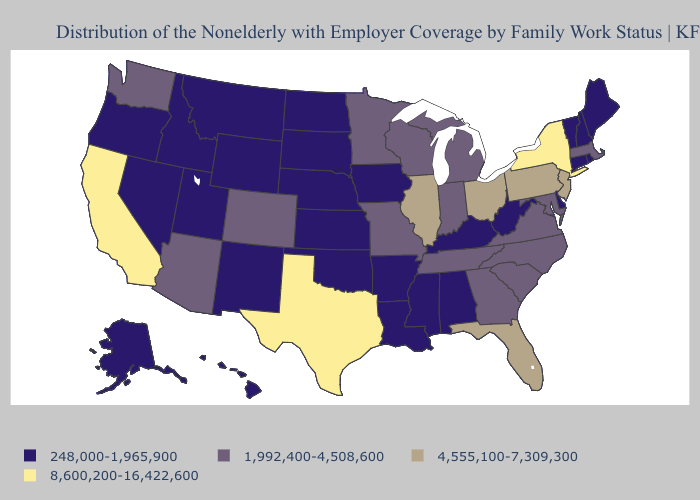Name the states that have a value in the range 8,600,200-16,422,600?
Be succinct. California, New York, Texas. Does New Jersey have the lowest value in the USA?
Write a very short answer. No. Among the states that border Texas , which have the lowest value?
Give a very brief answer. Arkansas, Louisiana, New Mexico, Oklahoma. Does the first symbol in the legend represent the smallest category?
Quick response, please. Yes. Name the states that have a value in the range 4,555,100-7,309,300?
Keep it brief. Florida, Illinois, New Jersey, Ohio, Pennsylvania. What is the value of Wyoming?
Be succinct. 248,000-1,965,900. What is the highest value in the South ?
Keep it brief. 8,600,200-16,422,600. Name the states that have a value in the range 248,000-1,965,900?
Answer briefly. Alabama, Alaska, Arkansas, Connecticut, Delaware, Hawaii, Idaho, Iowa, Kansas, Kentucky, Louisiana, Maine, Mississippi, Montana, Nebraska, Nevada, New Hampshire, New Mexico, North Dakota, Oklahoma, Oregon, Rhode Island, South Dakota, Utah, Vermont, West Virginia, Wyoming. Does the first symbol in the legend represent the smallest category?
Quick response, please. Yes. Does Pennsylvania have the lowest value in the USA?
Give a very brief answer. No. What is the lowest value in the USA?
Short answer required. 248,000-1,965,900. What is the value of Arkansas?
Quick response, please. 248,000-1,965,900. Among the states that border Colorado , which have the lowest value?
Short answer required. Kansas, Nebraska, New Mexico, Oklahoma, Utah, Wyoming. What is the value of New Jersey?
Write a very short answer. 4,555,100-7,309,300. Does New Hampshire have the lowest value in the Northeast?
Short answer required. Yes. 